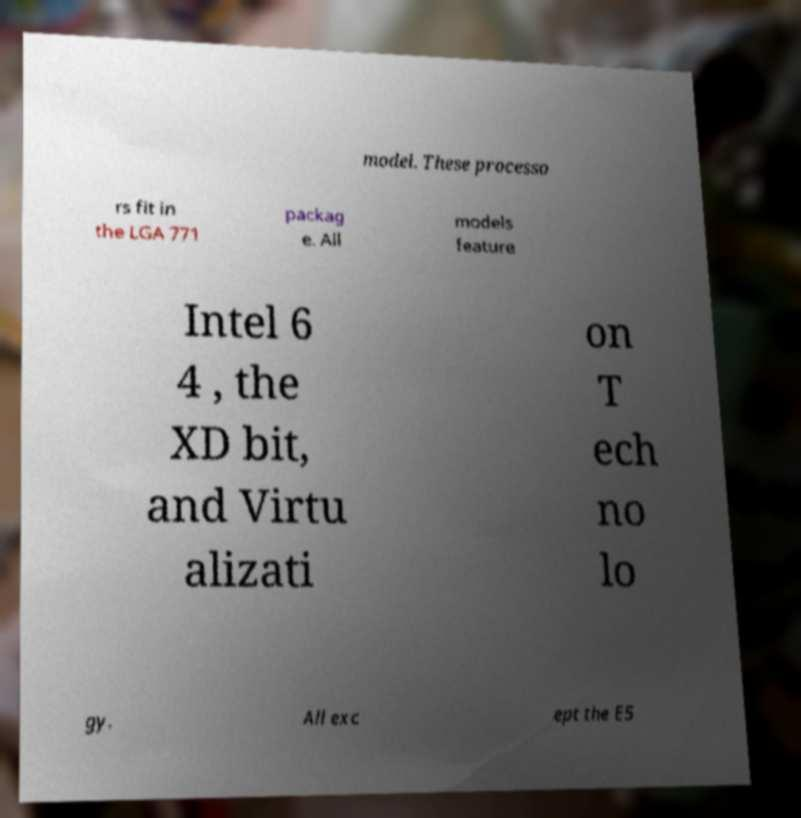Can you read and provide the text displayed in the image?This photo seems to have some interesting text. Can you extract and type it out for me? model. These processo rs fit in the LGA 771 packag e. All models feature Intel 6 4 , the XD bit, and Virtu alizati on T ech no lo gy. All exc ept the E5 